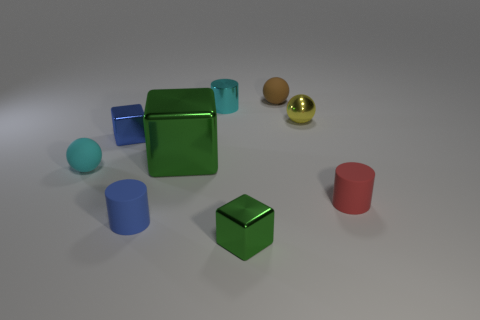There is a tiny block on the right side of the blue cylinder; is it the same color as the big metallic block?
Offer a terse response. Yes. How many things are brown objects or spheres?
Make the answer very short. 3. There is a matte ball that is on the right side of the tiny blue cube; what is its color?
Offer a very short reply. Brown. Are there fewer small blue rubber objects that are to the right of the blue rubber object than tiny yellow metal blocks?
Your response must be concise. No. What is the size of the matte thing that is the same color as the tiny shiny cylinder?
Your answer should be very brief. Small. Is there anything else that is the same size as the blue metallic object?
Offer a terse response. Yes. Is the material of the red object the same as the small brown object?
Your answer should be very brief. Yes. How many objects are rubber objects behind the blue matte object or things in front of the tiny red thing?
Keep it short and to the point. 5. Is there a cyan matte sphere of the same size as the yellow shiny sphere?
Your answer should be compact. Yes. There is another small matte thing that is the same shape as the tiny blue rubber thing; what is its color?
Make the answer very short. Red. 